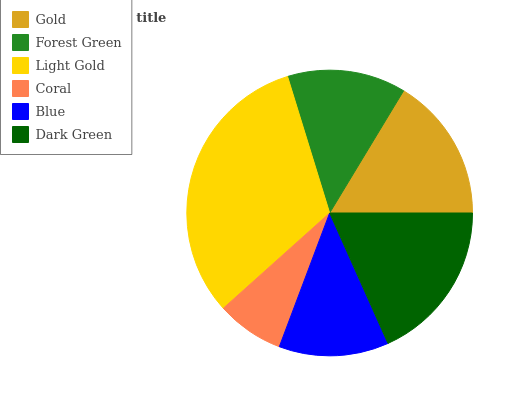Is Coral the minimum?
Answer yes or no. Yes. Is Light Gold the maximum?
Answer yes or no. Yes. Is Forest Green the minimum?
Answer yes or no. No. Is Forest Green the maximum?
Answer yes or no. No. Is Gold greater than Forest Green?
Answer yes or no. Yes. Is Forest Green less than Gold?
Answer yes or no. Yes. Is Forest Green greater than Gold?
Answer yes or no. No. Is Gold less than Forest Green?
Answer yes or no. No. Is Gold the high median?
Answer yes or no. Yes. Is Forest Green the low median?
Answer yes or no. Yes. Is Blue the high median?
Answer yes or no. No. Is Blue the low median?
Answer yes or no. No. 